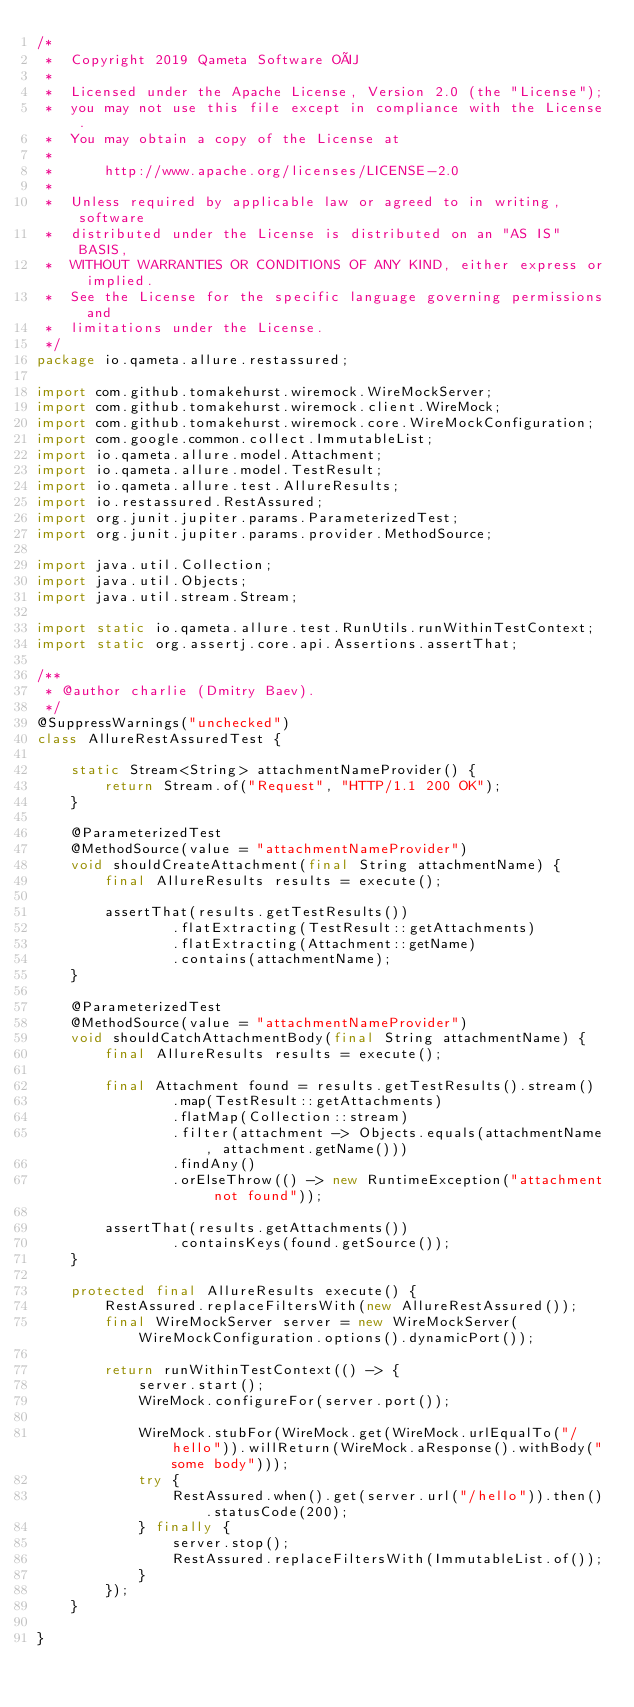Convert code to text. <code><loc_0><loc_0><loc_500><loc_500><_Java_>/*
 *  Copyright 2019 Qameta Software OÜ
 *
 *  Licensed under the Apache License, Version 2.0 (the "License");
 *  you may not use this file except in compliance with the License.
 *  You may obtain a copy of the License at
 *
 *      http://www.apache.org/licenses/LICENSE-2.0
 *
 *  Unless required by applicable law or agreed to in writing, software
 *  distributed under the License is distributed on an "AS IS" BASIS,
 *  WITHOUT WARRANTIES OR CONDITIONS OF ANY KIND, either express or implied.
 *  See the License for the specific language governing permissions and
 *  limitations under the License.
 */
package io.qameta.allure.restassured;

import com.github.tomakehurst.wiremock.WireMockServer;
import com.github.tomakehurst.wiremock.client.WireMock;
import com.github.tomakehurst.wiremock.core.WireMockConfiguration;
import com.google.common.collect.ImmutableList;
import io.qameta.allure.model.Attachment;
import io.qameta.allure.model.TestResult;
import io.qameta.allure.test.AllureResults;
import io.restassured.RestAssured;
import org.junit.jupiter.params.ParameterizedTest;
import org.junit.jupiter.params.provider.MethodSource;

import java.util.Collection;
import java.util.Objects;
import java.util.stream.Stream;

import static io.qameta.allure.test.RunUtils.runWithinTestContext;
import static org.assertj.core.api.Assertions.assertThat;

/**
 * @author charlie (Dmitry Baev).
 */
@SuppressWarnings("unchecked")
class AllureRestAssuredTest {

    static Stream<String> attachmentNameProvider() {
        return Stream.of("Request", "HTTP/1.1 200 OK");
    }

    @ParameterizedTest
    @MethodSource(value = "attachmentNameProvider")
    void shouldCreateAttachment(final String attachmentName) {
        final AllureResults results = execute();

        assertThat(results.getTestResults())
                .flatExtracting(TestResult::getAttachments)
                .flatExtracting(Attachment::getName)
                .contains(attachmentName);
    }

    @ParameterizedTest
    @MethodSource(value = "attachmentNameProvider")
    void shouldCatchAttachmentBody(final String attachmentName) {
        final AllureResults results = execute();

        final Attachment found = results.getTestResults().stream()
                .map(TestResult::getAttachments)
                .flatMap(Collection::stream)
                .filter(attachment -> Objects.equals(attachmentName, attachment.getName()))
                .findAny()
                .orElseThrow(() -> new RuntimeException("attachment not found"));

        assertThat(results.getAttachments())
                .containsKeys(found.getSource());
    }

    protected final AllureResults execute() {
        RestAssured.replaceFiltersWith(new AllureRestAssured());
        final WireMockServer server = new WireMockServer(WireMockConfiguration.options().dynamicPort());

        return runWithinTestContext(() -> {
            server.start();
            WireMock.configureFor(server.port());

            WireMock.stubFor(WireMock.get(WireMock.urlEqualTo("/hello")).willReturn(WireMock.aResponse().withBody("some body")));
            try {
                RestAssured.when().get(server.url("/hello")).then().statusCode(200);
            } finally {
                server.stop();
                RestAssured.replaceFiltersWith(ImmutableList.of());
            }
        });
    }

}
</code> 